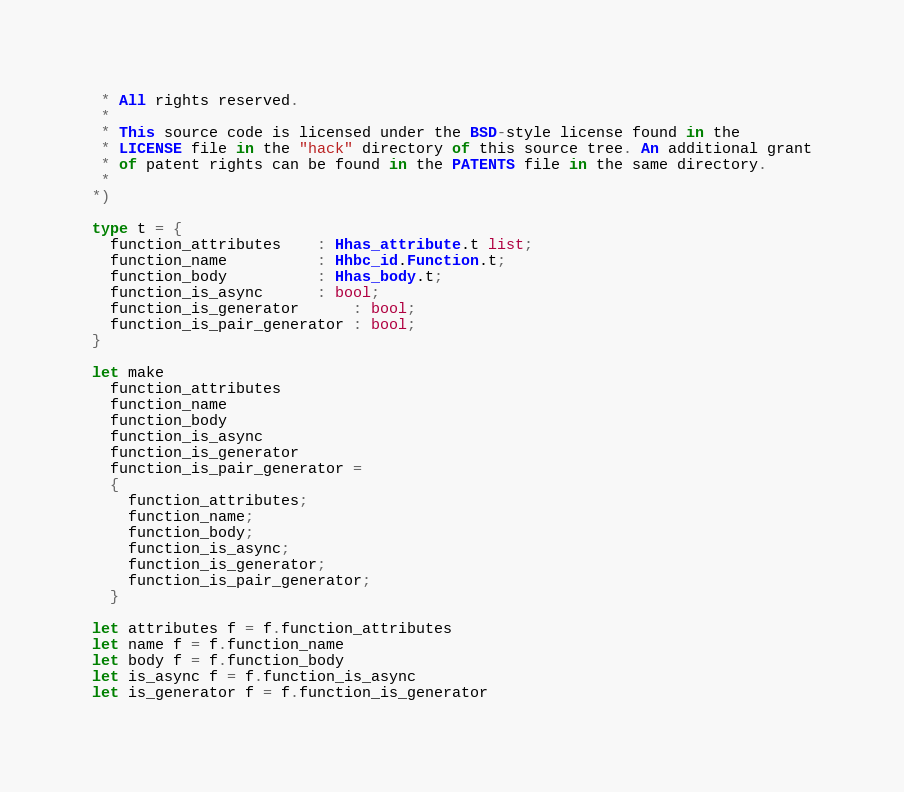<code> <loc_0><loc_0><loc_500><loc_500><_OCaml_> * All rights reserved.
 *
 * This source code is licensed under the BSD-style license found in the
 * LICENSE file in the "hack" directory of this source tree. An additional grant
 * of patent rights can be found in the PATENTS file in the same directory.
 *
*)

type t = {
  function_attributes    : Hhas_attribute.t list;
  function_name          : Hhbc_id.Function.t;
  function_body          : Hhas_body.t;
  function_is_async      : bool;
  function_is_generator      : bool;
  function_is_pair_generator : bool;
}

let make
  function_attributes
  function_name
  function_body
  function_is_async
  function_is_generator
  function_is_pair_generator =
  {
    function_attributes;
    function_name;
    function_body;
    function_is_async;
    function_is_generator;
    function_is_pair_generator;
  }

let attributes f = f.function_attributes
let name f = f.function_name
let body f = f.function_body
let is_async f = f.function_is_async
let is_generator f = f.function_is_generator</code> 